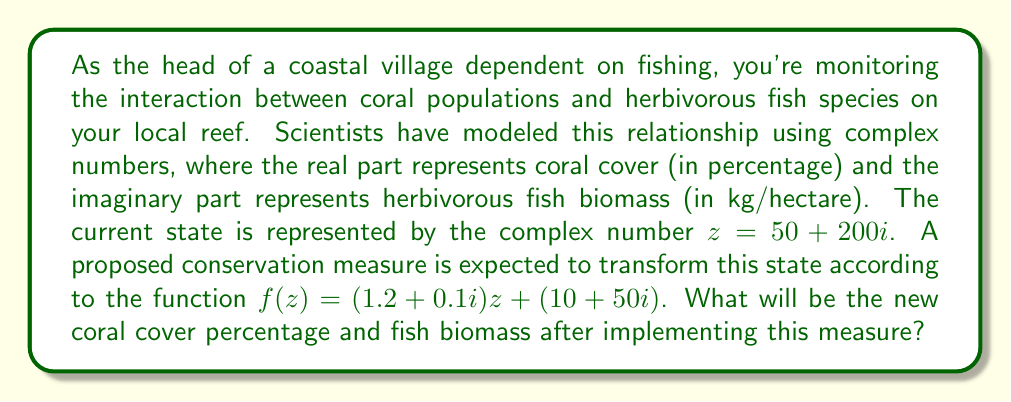Help me with this question. To solve this problem, we need to apply the given complex transformation to the initial state:

1) Start with the initial state: $z = 50 + 200i$

2) Apply the transformation: $f(z) = (1.2 + 0.1i)z + (10 + 50i)$

3) Expand the multiplication:
   $$(1.2 + 0.1i)(50 + 200i) + (10 + 50i)$$
   
   $= (1.2 \cdot 50 + 1.2 \cdot 200i + 0.1i \cdot 50 + 0.1i \cdot 200i) + (10 + 50i)$
   
   $= (60 + 240i + 5i - 20) + (10 + 50i)$
   
   $= (60 - 20 + 240i + 5i) + (10 + 50i)$
   
   $= 40 + 245i + 10 + 50i$

4) Combine like terms:
   $= 50 + 295i$

5) Interpret the result:
   - The real part (50) represents the new coral cover percentage.
   - The imaginary part (295) represents the new herbivorous fish biomass in kg/hectare.

Therefore, after implementing the conservation measure, the coral cover will be 50% and the herbivorous fish biomass will be 295 kg/hectare.
Answer: The new coral cover will be 50% and the new herbivorous fish biomass will be 295 kg/hectare. 